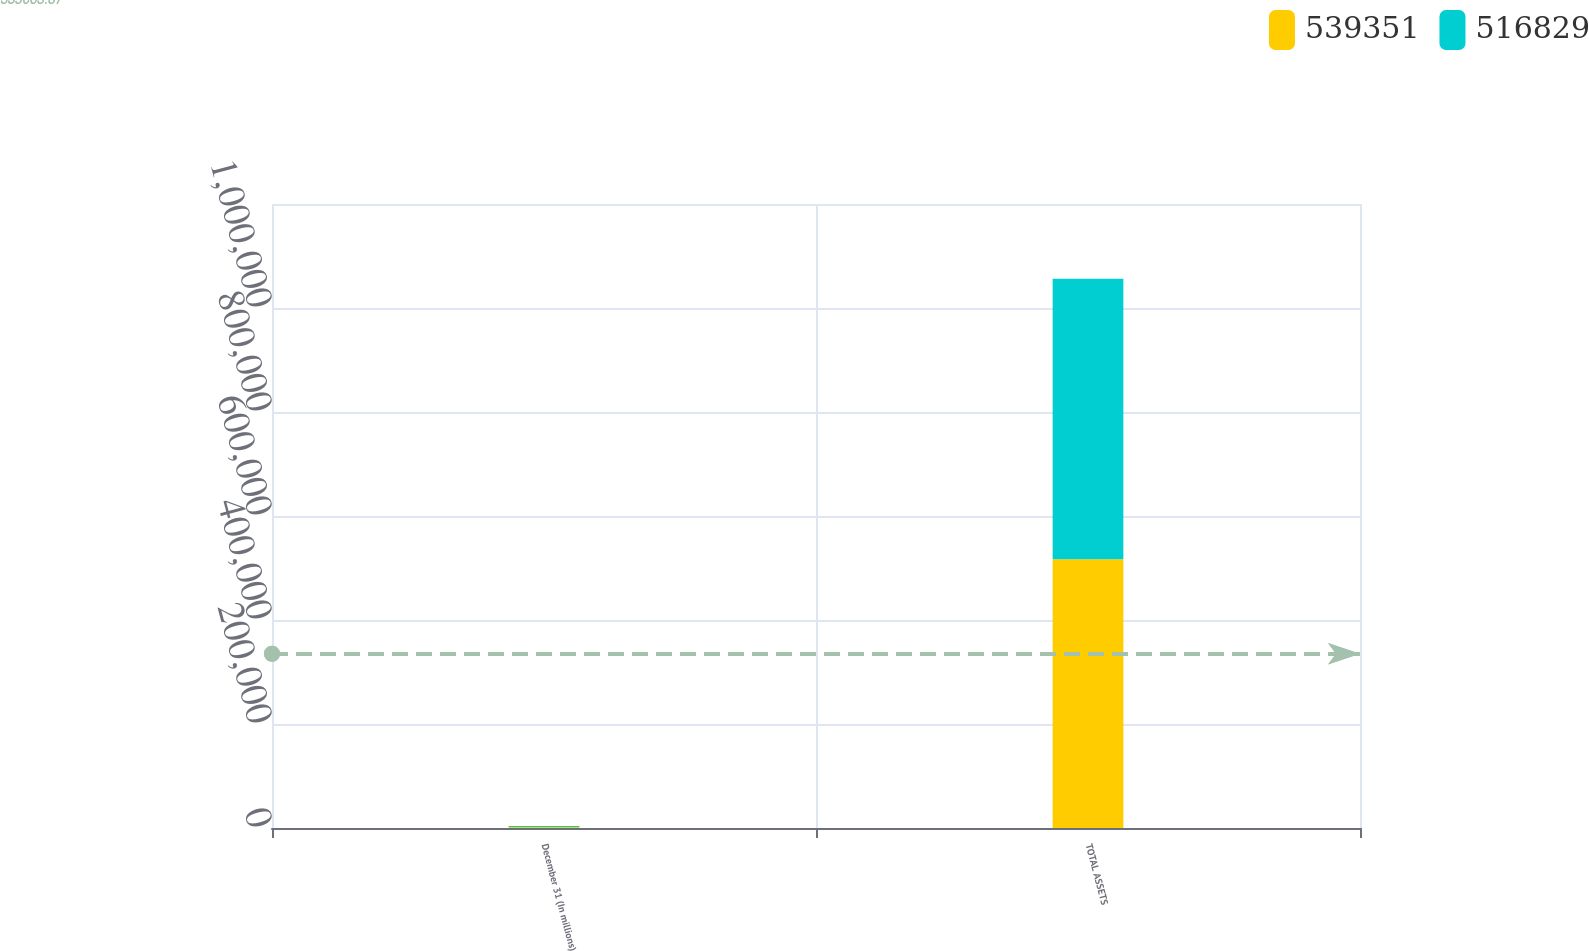Convert chart to OTSL. <chart><loc_0><loc_0><loc_500><loc_500><stacked_bar_chart><ecel><fcel>December 31 (In millions)<fcel>TOTAL ASSETS<nl><fcel>539351<fcel>2013<fcel>516829<nl><fcel>516829<fcel>2012<fcel>539351<nl></chart> 